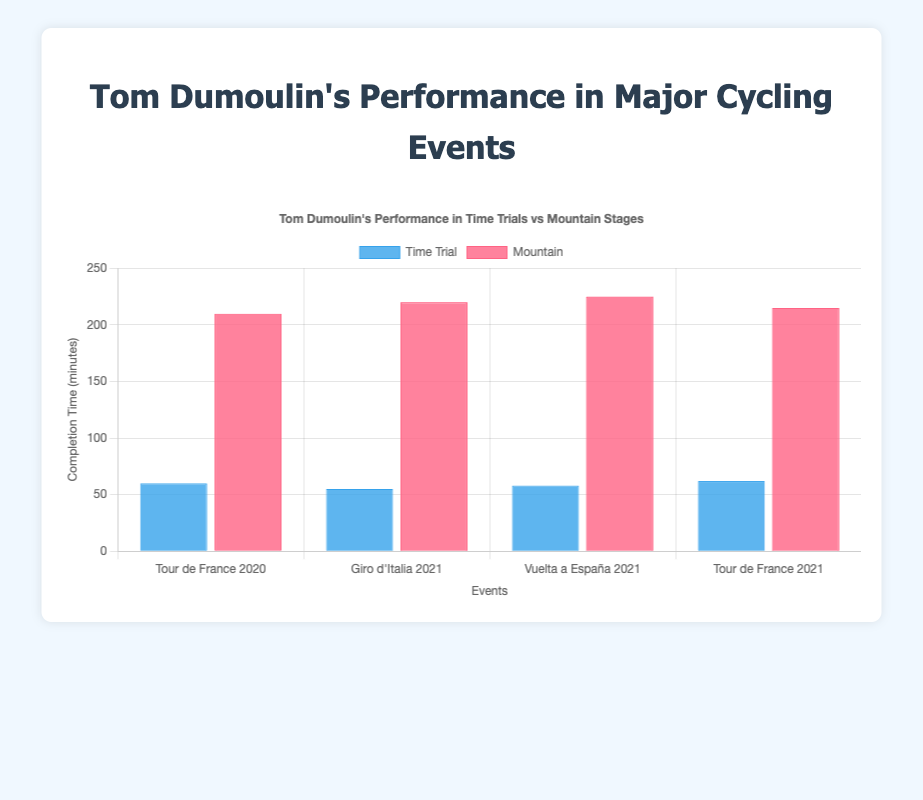Which event had the shortest completion time for a time trial? The shortest completion time for a time trial can be found by identifying the smallest height of the blue bars representing time trials. Among the events, the shortest time is from the Giro d'Italia 2021.
Answer: Giro d'Italia 2021 How much longer did Tom Dumoulin take to complete the mountain stage compared to the time trial in the Vuelta a España 2021? To calculate the difference, find the completion times for both stages in the Vuelta a España 2021. For the time trial, it's 58 minutes, and for the mountain stage, it's 225 minutes. The difference is 225 - 58.
Answer: 167 minutes In which event did Tom Dumoulin have the highest rank in the mountain stage? Compare the ranks of Tom Dumoulin in the mountain stages across all events. The highest rank (lowest numerical value) is 4 during the Vuelta a España 2021.
Answer: Vuelta a España 2021 What is the average completion time for Tom Dumoulin's time trials across all events? Calculate the average by summing the completion times for time trials (60 + 55 + 58 + 62) and then dividing by the number of events (4). The sum is 235, and the average is 235/4.
Answer: 58.75 minutes Which event showed the smallest difference in completion time between the time trial and the mountain stage? To find the smallest difference, calculate the differences for each event (Tour de France 2020: 210 - 60 = 150, Giro d'Italia 2021: 220 - 55 = 165, Vuelta a España 2021: 225 - 58 = 167, Tour de France 2021: 215 - 62 = 153). The smallest difference is 150 from the Tour de France 2020.
Answer: Tour de France 2020 Did Tom Dumoulin perform better in time trials or mountain stages in terms of ranking? Summarize the ranks for both time trials and mountain stages: time trials (2, 1, 3, 4) and mountain stages (5, 6, 4, 5). Calculate the average rank for each: time trials (2+1+3+4)/4 = 2.5, mountain stages (5+6+4+5)/4 = 5. Tom Dumoulin has a better (lower) average rank in time trials.
Answer: Time trials In what event did Tom Dumoulin take the longest time to complete a mountain stage? Identify the mountain stage completion times for all events and select the highest. The longest time is 225 minutes from the Vuelta a España 2021.
Answer: Vuelta a España 2021 Considering only mountain stages, what is Tom Dumoulin's average rank? Calculate the average rank by summing the ranks for the mountain stages (5, 6, 4, 5) and then dividing by the number of events (4). The sum is 20, and the average rank is 20/4.
Answer: 5 Which event had the largest variation between the completion times for time trials and mountain stages? Calculate the absolute differences for each event: Tour de France 2020 (150 minutes), Giro d'Italia 2021 (165 minutes), Vuelta a España 2021 (167 minutes), and Tour de France 2021 (153 minutes). The largest variation is 167 minutes during the Vuelta a España 2021.
Answer: Vuelta a España 2021 In the 2021 Tour de France, how did Tom Dumoulin's time trial completion time compare with the other events? Compare the time trial completion times: Tour de France 2021 (62 minutes) with Tour de France 2020 (60 minutes), Giro d'Italia 2021 (55 minutes), and Vuelta a España 2021 (58 minutes). The 2021 Tour de France time trial time is longer than all other events.
Answer: Longer 